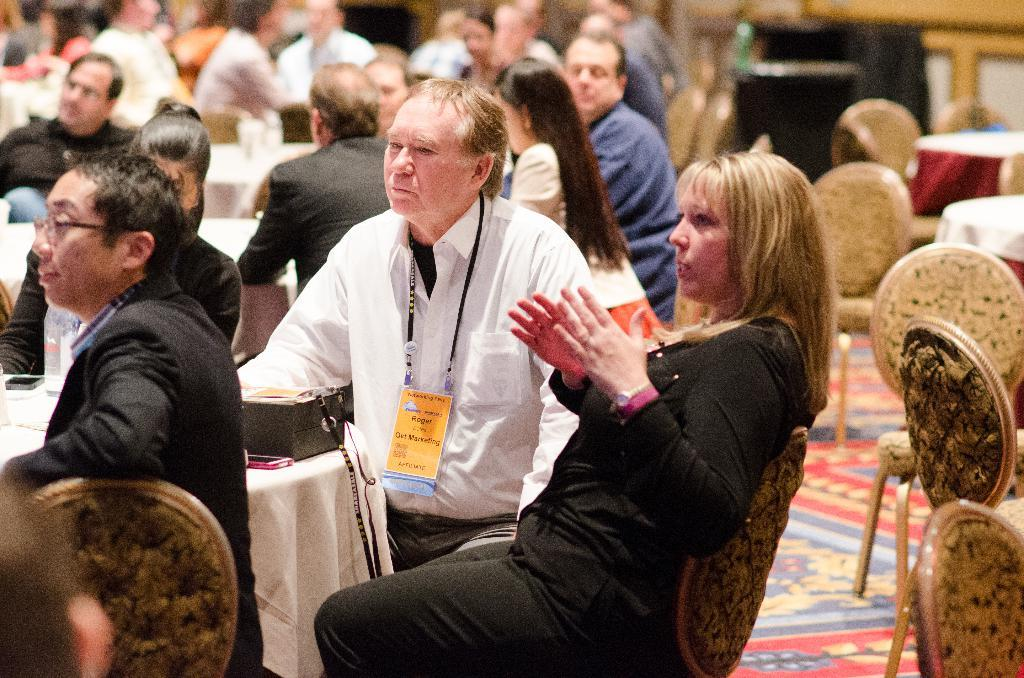What is happening in the image? There is a group of people sitting in the image. Can you describe the clothing of one of the individuals? One person is wearing a black color dress. What else can be seen in the image besides the group of people? There are objects on a table in the image. What direction is the army coming from in the image? There is no army present in the image, so it is not possible to determine the direction from which they might be coming. 